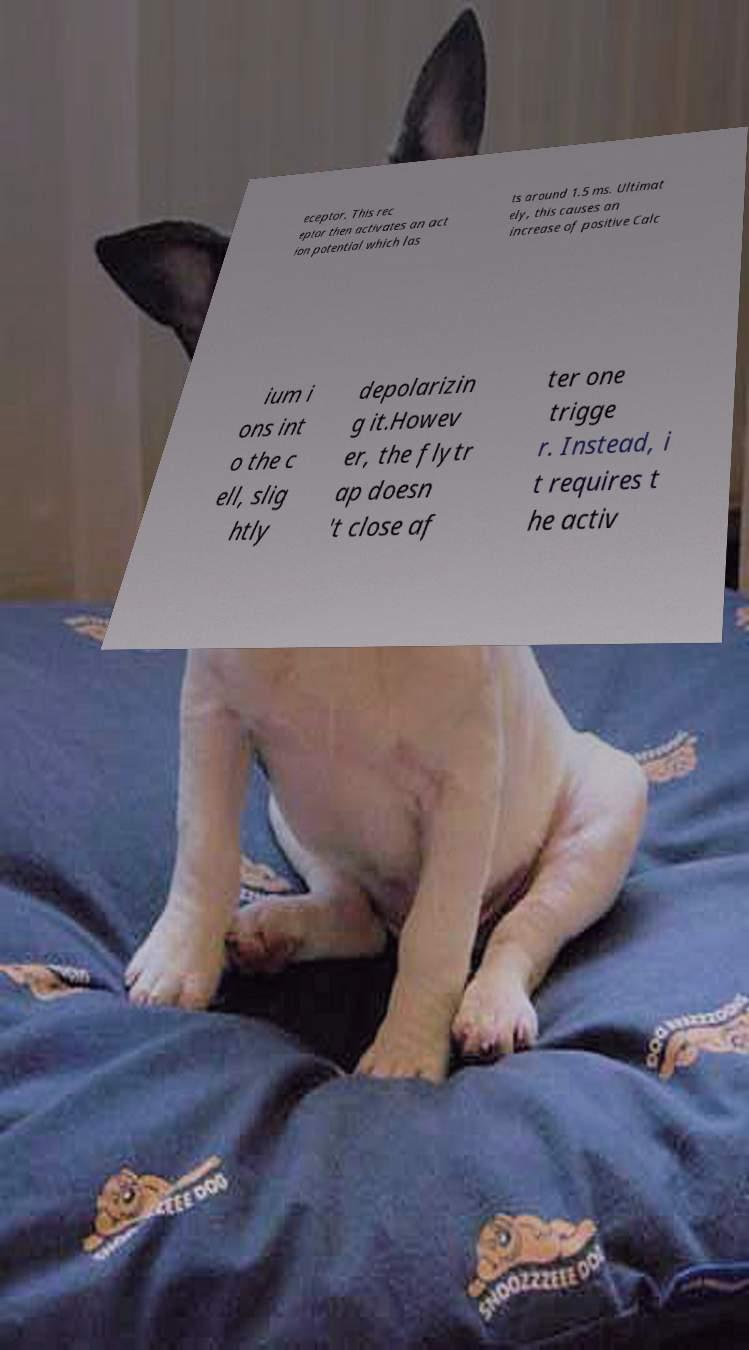Please identify and transcribe the text found in this image. eceptor. This rec eptor then activates an act ion potential which las ts around 1.5 ms. Ultimat ely, this causes an increase of positive Calc ium i ons int o the c ell, slig htly depolarizin g it.Howev er, the flytr ap doesn 't close af ter one trigge r. Instead, i t requires t he activ 